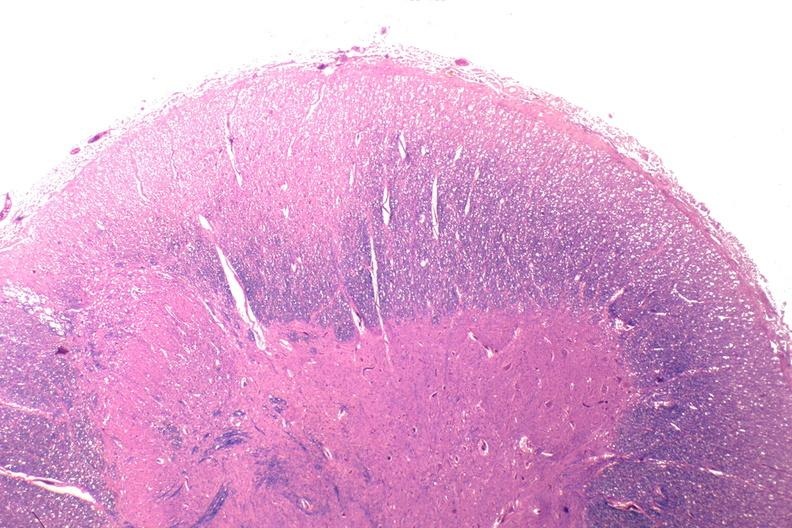what does this image show?
Answer the question using a single word or phrase. Spinal cord injury due to vertebral column trauma 